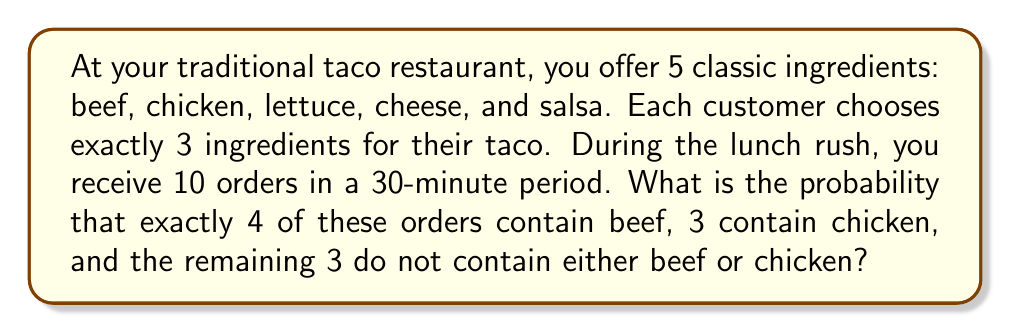Show me your answer to this math problem. Let's approach this step-by-step:

1) First, we need to calculate the total number of ways to choose 3 ingredients out of 5:
   $${5 \choose 3} = \frac{5!}{3!(5-3)!} = 10$$

2) Now, let's consider the probability of each type of order:

   a) For beef orders: 
      Probability = $\frac{\text{ways to choose beef and 2 other ingredients}}{\text{total ways}} = \frac{4 \choose 2}{10} = \frac{6}{10}$

   b) For chicken orders:
      Probability = $\frac{\text{ways to choose chicken and 2 other ingredients}}{\text{total ways}} = \frac{4 \choose 2}{10} = \frac{6}{10}$

   c) For orders without beef or chicken:
      Probability = $\frac{\text{ways to choose 3 from remaining 3 ingredients}}{\text{total ways}} = \frac{1}{10}$

3) The scenario we're looking for follows a multinomial distribution with 10 trials and 3 outcomes:
   4 beef orders, 3 chicken orders, and 3 neither beef nor chicken orders.

4) The probability is given by the multinomial probability formula:

   $$P(X_1=4, X_2=3, X_3=3) = \frac{10!}{4!3!3!} \left(\frac{6}{10}\right)^4 \left(\frac{6}{10}\right)^3 \left(\frac{1}{10}\right)^3$$

5) Calculating this:
   $$\frac{10!}{4!3!3!} = 4200$$
   $$\left(\frac{6}{10}\right)^4 \left(\frac{6}{10}\right)^3 \left(\frac{1}{10}\right)^3 = \frac{6^7}{10^{10}}$$

   $$4200 \cdot \frac{6^7}{10^{10}} = \frac{4200 \cdot 279936}{10000000000} = \frac{1175731200}{10000000000} = 0.11757312$$
Answer: $\frac{1175731200}{10000000000} \approx 0.1176$ 